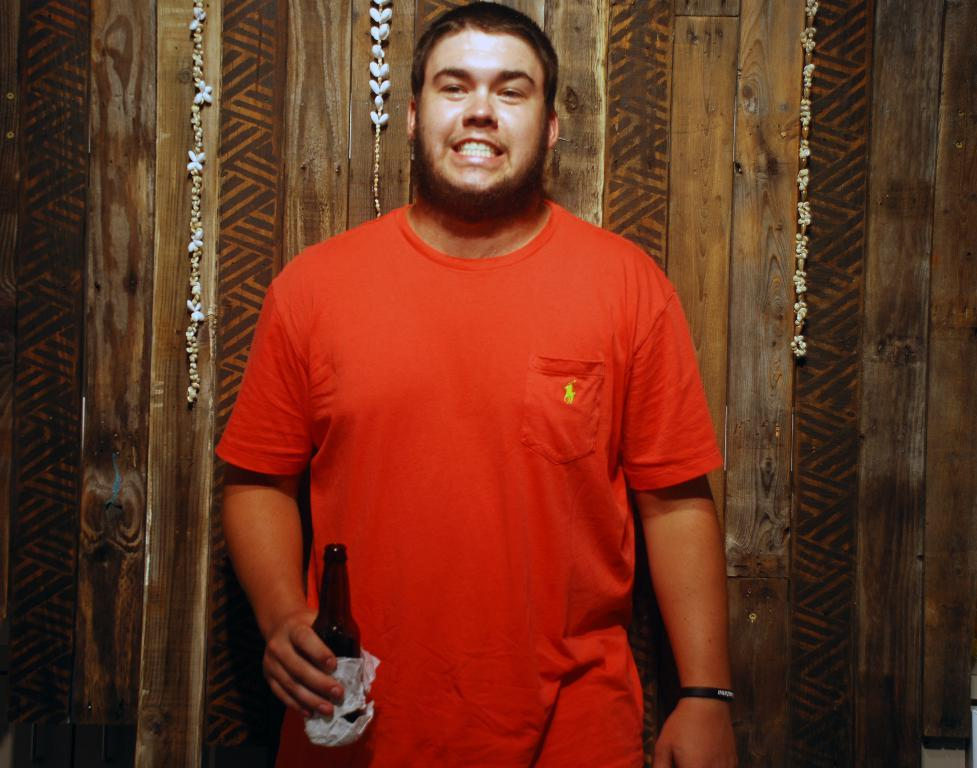Who is present in the image? There is a man in the image. What is the man holding in his hand? The man is holding a bottle in his hand. What color is the t-shirt the man is wearing? The man is wearing a red t-shirt. What type of cake is the man holding in the image? There is no cake present in the image; the man is holding a bottle. 